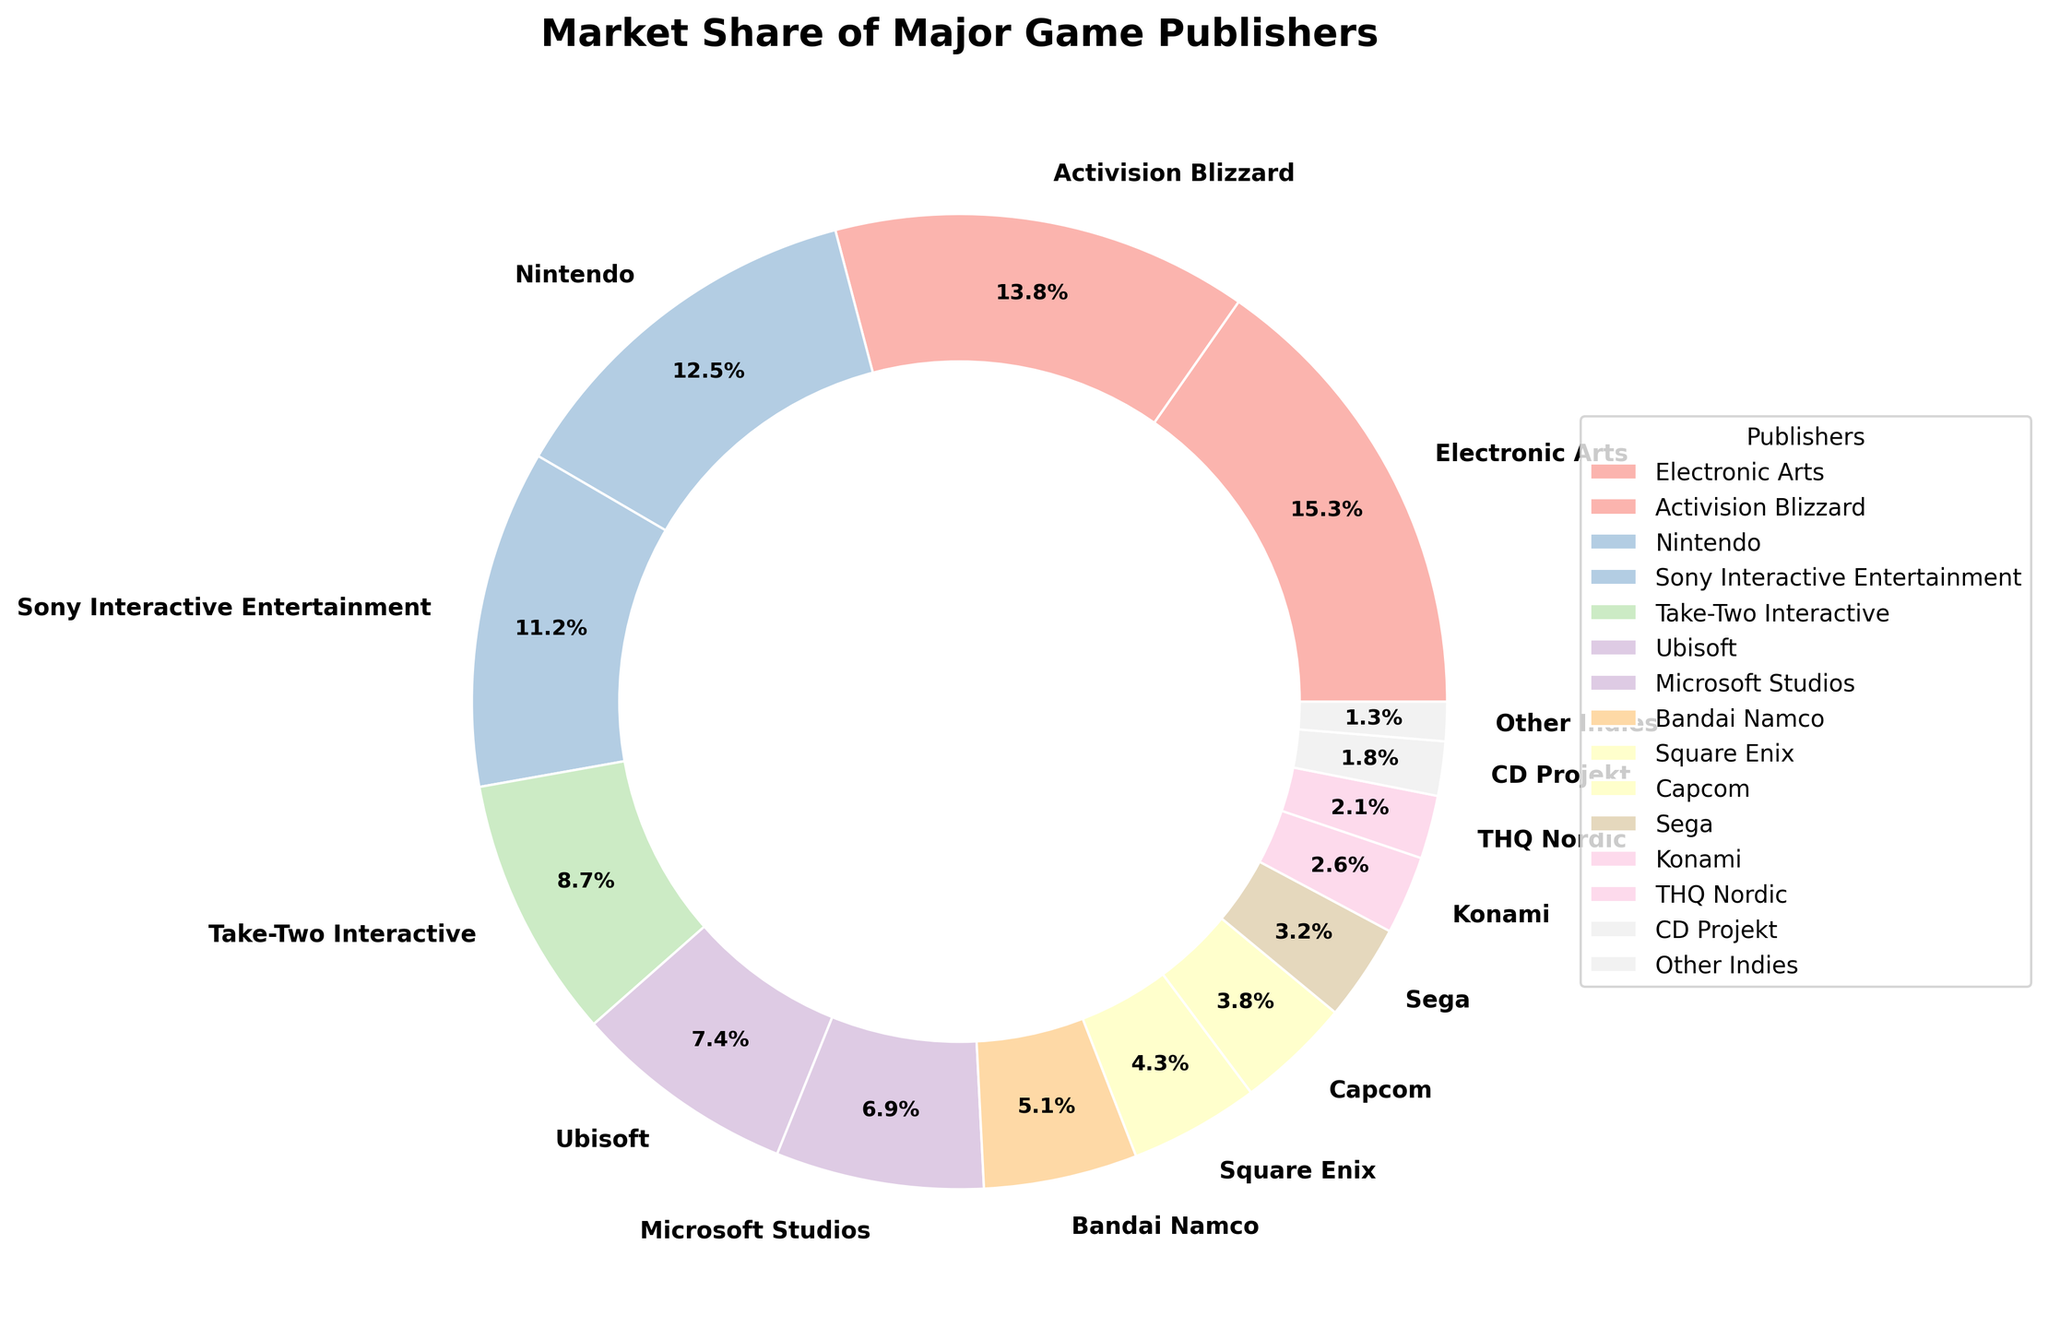What percentage of the market share is covered by Electronic Arts and Activision Blizzard combined? Add the market share percentages of Electronic Arts (15.3%) and Activision Blizzard (13.8%) together: 15.3 + 13.8 = 29.1
Answer: 29.1% Which publisher has a higher market share, Nintendo or Sony Interactive Entertainment, and by how much? Compare the market share percentages of Nintendo (12.5%) and Sony Interactive Entertainment (11.2%). Subtract the smaller from the larger: 12.5 - 11.2 = 1.3
Answer: Nintendo by 1.3% What is the total market share of publishers with less than 5% market share? Add the market share percentages of Bandai Namco (5.1% > 5%), Square Enix (4.3%), Capcom (3.8%), Sega (3.2%), Konami (2.6%), THQ Nordic (2.1%), CD Projekt (1.8%), and Other Indies (1.3%): 4.3 + 3.8 + 3.2 + 2.6 + 2.1 + 1.8 + 1.3 = 17.1
Answer: 17.1% Which publisher has the smallest market share, and what is the percentage? Identify the publisher with the smallest wedge in the pie chart, which represents Other Indies at 1.3%.
Answer: Other Indies, 1.3% What is the difference in market share between Ubisoft and Microsoft Studios? Compare the market share percentages of Ubisoft (7.4%) and Microsoft Studios (6.9%). Subtract the smaller from the larger: 7.4 - 6.9 = 0.5
Answer: 0.5% Do the top three publishers combined have a majority of the market share? Add the market share percentages of the top three publishers: Electronic Arts (15.3%), Activision Blizzard (13.8%), and Nintendo (12.5%): 15.3 + 13.8 + 12.5 = 41.6. Since 41.6% is less than 50%, they do not have a majority.
Answer: No, 41.6% Which publisher is represented by a wedge in the pie chart that is primarily pink? Identify the color associated with the third largest wedge, which is pink and represents Nintendo.
Answer: Nintendo What is the average market share percentage of Electronic Arts, Activision Blizzard, and Nintendo? Add the market share percentages of Electronic Arts (15.3%), Activision Blizzard (13.8%), and Nintendo (12.5%), then divide by the number of publishers: (15.3 + 13.8 + 12.5) / 3 = 41.6 / 3 ≈ 13.87
Answer: 13.87% How many publishers have a market share between 5% and 10%? Count the publishers that fall within the 5%-10% range: Take-Two Interactive (8.7%), Ubisoft (7.4%), and Microsoft Studios (6.9%) Total = 3
Answer: 3 